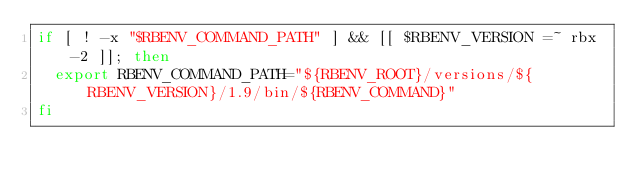<code> <loc_0><loc_0><loc_500><loc_500><_Bash_>if [ ! -x "$RBENV_COMMAND_PATH" ] && [[ $RBENV_VERSION =~ rbx-2 ]]; then
  export RBENV_COMMAND_PATH="${RBENV_ROOT}/versions/${RBENV_VERSION}/1.9/bin/${RBENV_COMMAND}"
fi
</code> 